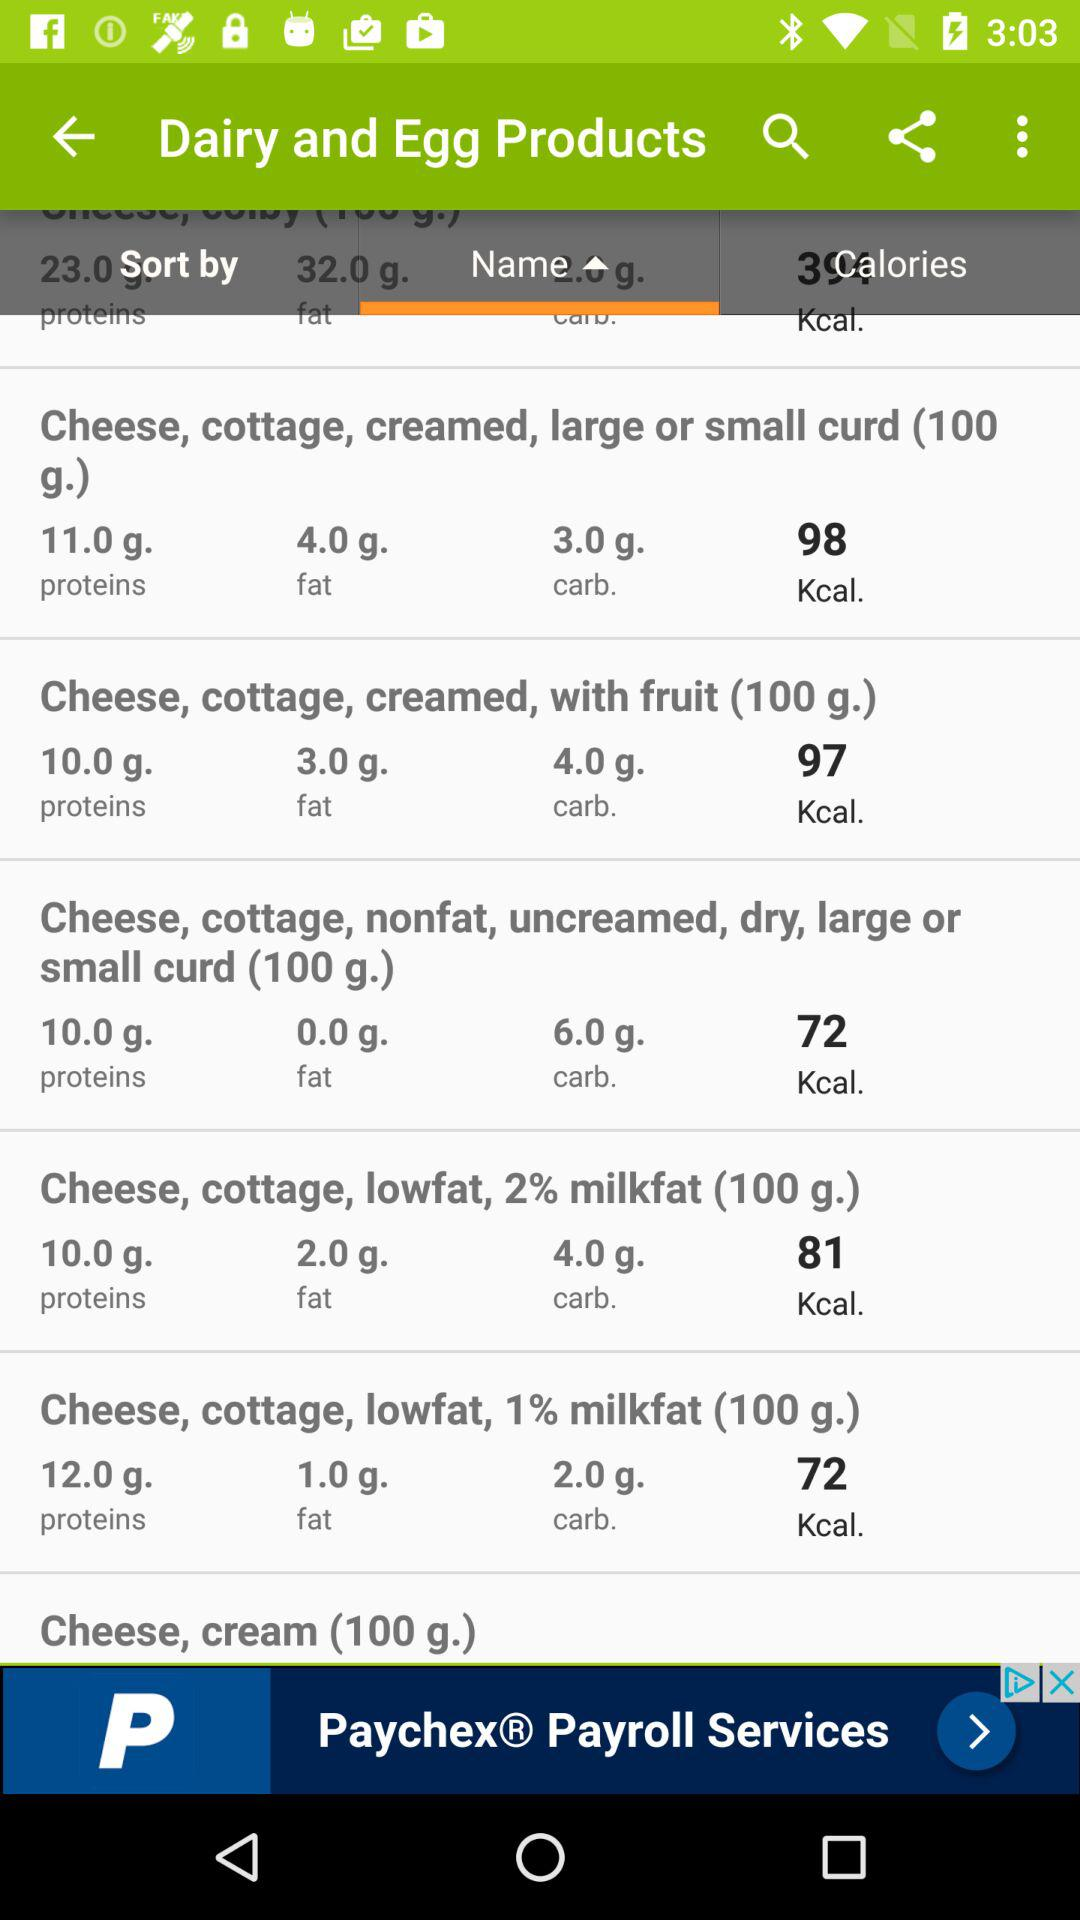How much protein "Cheese, cottage, lowfat, 2% milkfat (100g.)" contain? The protein it contains is 10 grams. 